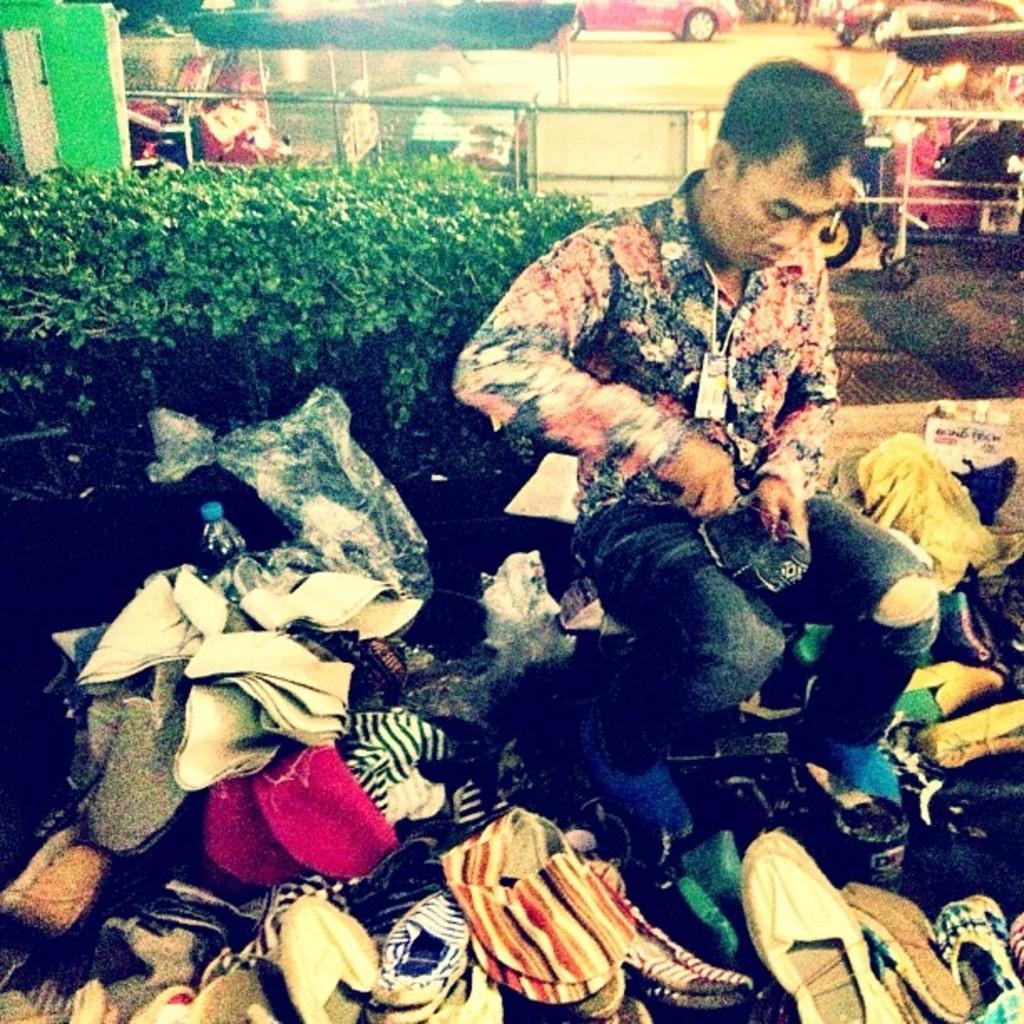In one or two sentences, can you explain what this image depicts? In this picture we can see a man holding an object with his hands and in front of him we can see footwear, clothes, bottle and in the background we can see plants, fence, vehicles and some objects. 